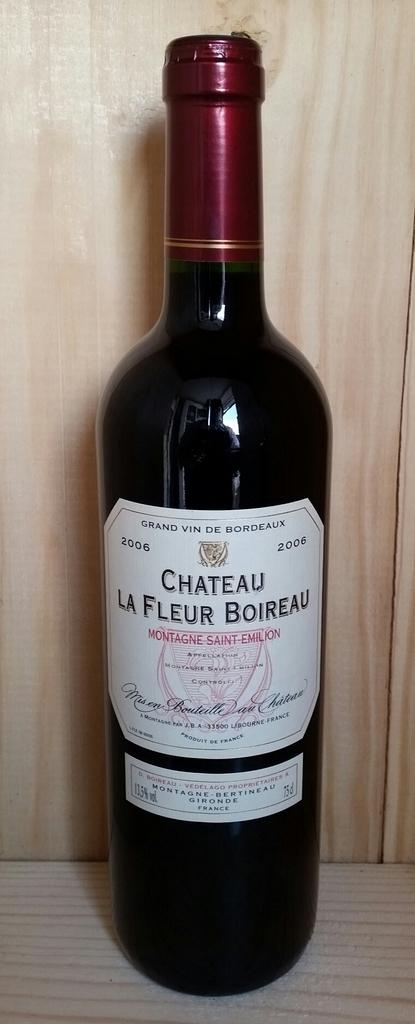<image>
Present a compact description of the photo's key features. Wine bottle named Chateau La Fleur Boireau placed on a wooden surface. 